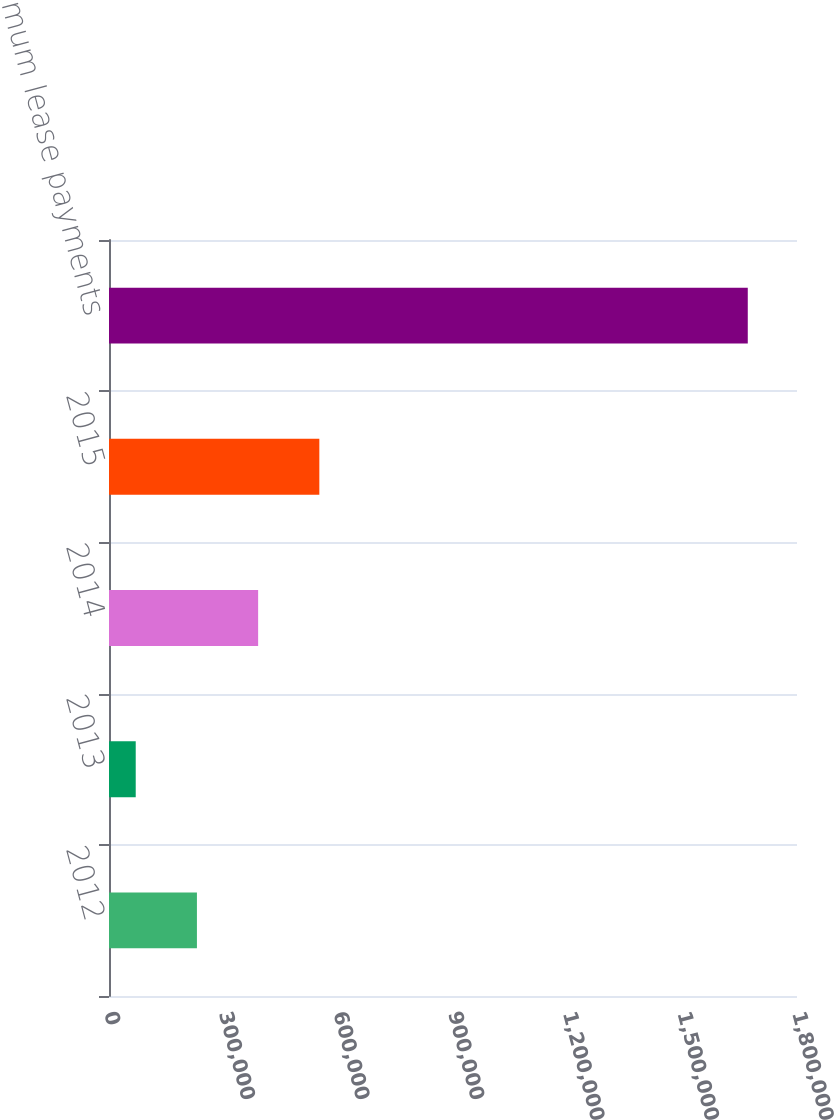<chart> <loc_0><loc_0><loc_500><loc_500><bar_chart><fcel>2012<fcel>2013<fcel>2014<fcel>2015<fcel>Total minimum lease payments<nl><fcel>230047<fcel>69917<fcel>390176<fcel>550306<fcel>1.67121e+06<nl></chart> 